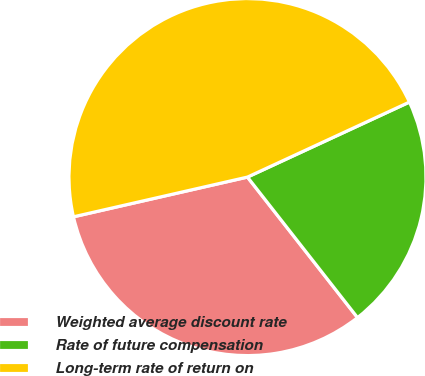<chart> <loc_0><loc_0><loc_500><loc_500><pie_chart><fcel>Weighted average discount rate<fcel>Rate of future compensation<fcel>Long-term rate of return on<nl><fcel>32.0%<fcel>21.33%<fcel>46.67%<nl></chart> 